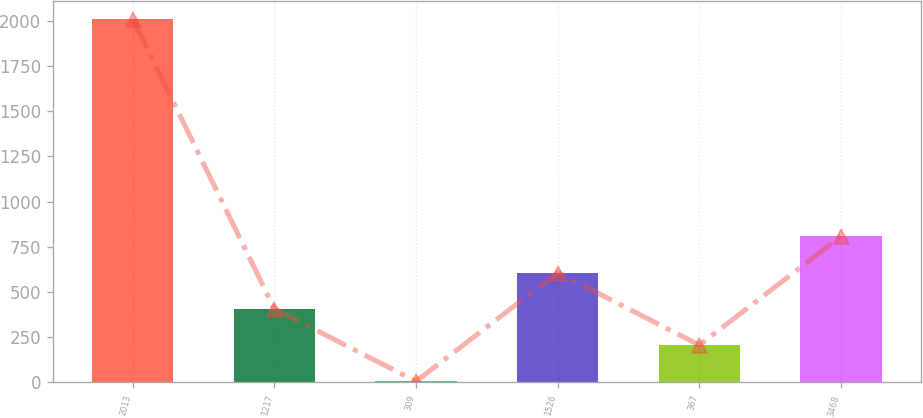<chart> <loc_0><loc_0><loc_500><loc_500><bar_chart><fcel>2013<fcel>1217<fcel>309<fcel>1526<fcel>367<fcel>3468<nl><fcel>2011<fcel>407<fcel>6<fcel>607.5<fcel>206.5<fcel>808<nl></chart> 